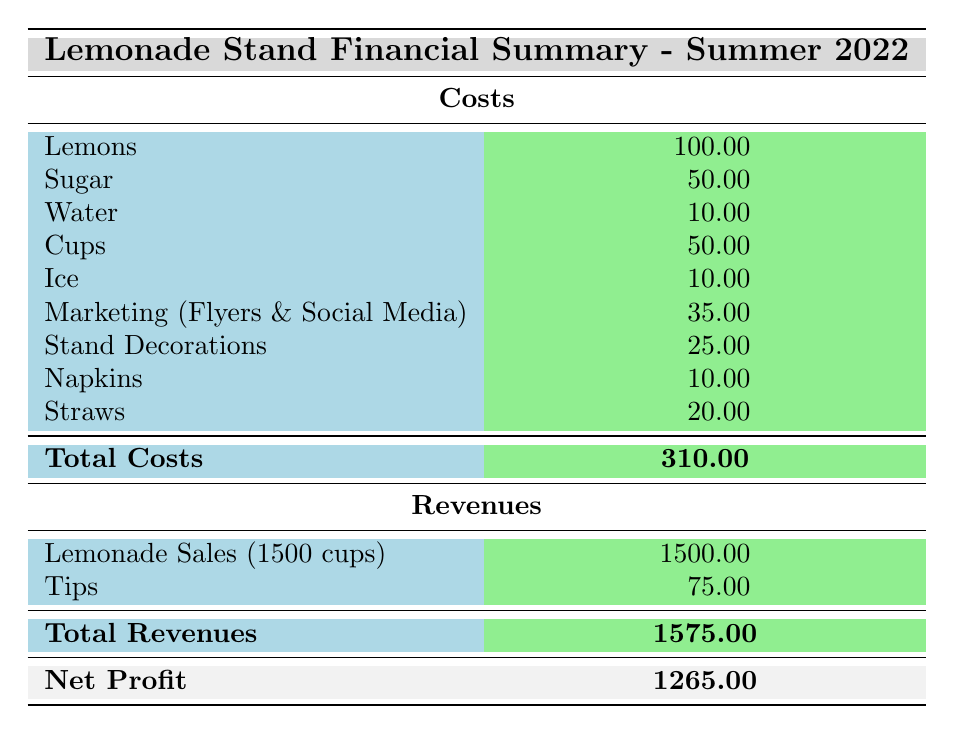What are the total costs for the lemonade stand? The total costs are listed directly in the table. It states that the total costs amount to 310.00.
Answer: 310.00 How much did the lemonade stand earn from lemonade sales? The table reports the total revenue from lemonade sales as 1500.00, which is explicitly stated under revenues.
Answer: 1500.00 Did the lemonade stand make a profit? To check if there was a profit, we need to compare total revenues (1575.00) with total costs (310.00). Since total revenues exceed total costs, the answer is yes.
Answer: Yes What is the total expenditure on marketing? The marketing costs can be found by adding the costs for flyers (20.00) and social media ads (15.00), which gives 35.00.
Answer: 35.00 How much more did the lemonade stand earn from tips compared to ice costs? The tips total 75.00, and ice costs 10.00. The difference is computed as 75.00 - 10.00 = 65.00.
Answer: 65.00 What percentage of the total costs was spent on lemons? The cost of lemons is 100.00, while total costs are 310.00. To find the percentage, we calculate (100.00 / 310.00) * 100, which yields approximately 32.26%.
Answer: 32.26% How much did the lemonade stand spend in total on cups and ice combined? The cost of cups is 50.00, and the cost of ice is 10.00. Adding these together gives 50.00 + 10.00 = 60.00.
Answer: 60.00 What is the difference between total revenues and total costs? To find the difference, subtract total costs (310.00) from total revenues (1575.00), resulting in 1575.00 - 310.00 = 1265.00.
Answer: 1265.00 Was the total revenue from lemonade sales higher than the combined total costs for all items? The total revenue from lemonade sales is 1500.00, while the total costs are 310.00. Since 1500.00 is greater than 310.00, the answer is yes.
Answer: Yes 